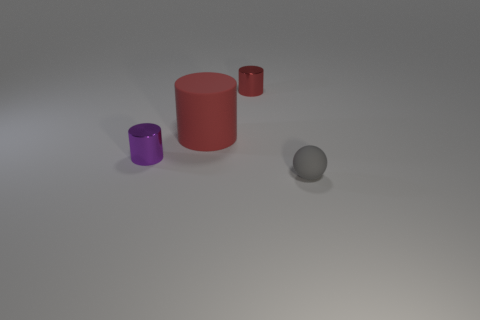What number of other things are there of the same shape as the red rubber thing?
Provide a short and direct response. 2. There is a matte thing that is left of the tiny ball; does it have the same shape as the small gray thing?
Your answer should be compact. No. Are there any small metal things to the left of the purple object?
Ensure brevity in your answer.  No. What number of small objects are either matte things or metallic cylinders?
Offer a very short reply. 3. Are the tiny red object and the tiny gray object made of the same material?
Give a very brief answer. No. The other shiny cylinder that is the same color as the large cylinder is what size?
Your response must be concise. Small. Are there any tiny matte spheres that have the same color as the big thing?
Give a very brief answer. No. What is the size of the other object that is made of the same material as the purple thing?
Provide a succinct answer. Small. There is a small shiny object in front of the red thing that is behind the matte thing that is to the left of the tiny rubber thing; what shape is it?
Your response must be concise. Cylinder. What size is the red shiny object that is the same shape as the big red rubber object?
Ensure brevity in your answer.  Small. 